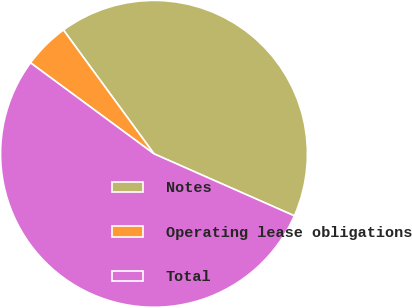Convert chart to OTSL. <chart><loc_0><loc_0><loc_500><loc_500><pie_chart><fcel>Notes<fcel>Operating lease obligations<fcel>Total<nl><fcel>41.67%<fcel>4.84%<fcel>53.49%<nl></chart> 